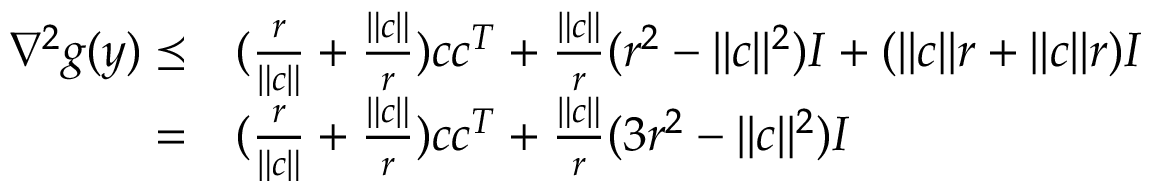<formula> <loc_0><loc_0><loc_500><loc_500>\begin{array} { r l } { \nabla ^ { 2 } g ( y ) \preceq } & { ( \frac { r } { \| c \| } + \frac { \| c \| } { r } ) c c ^ { T } + \frac { \| c \| } { r } ( r ^ { 2 } - \| c \| ^ { 2 } ) I + ( \| c \| r + \| c \| r ) I } \\ { = } & { ( \frac { r } { \| c \| } + \frac { \| c \| } { r } ) c c ^ { T } + \frac { \| c \| } { r } ( 3 r ^ { 2 } - \| c \| ^ { 2 } ) I } \end{array}</formula> 